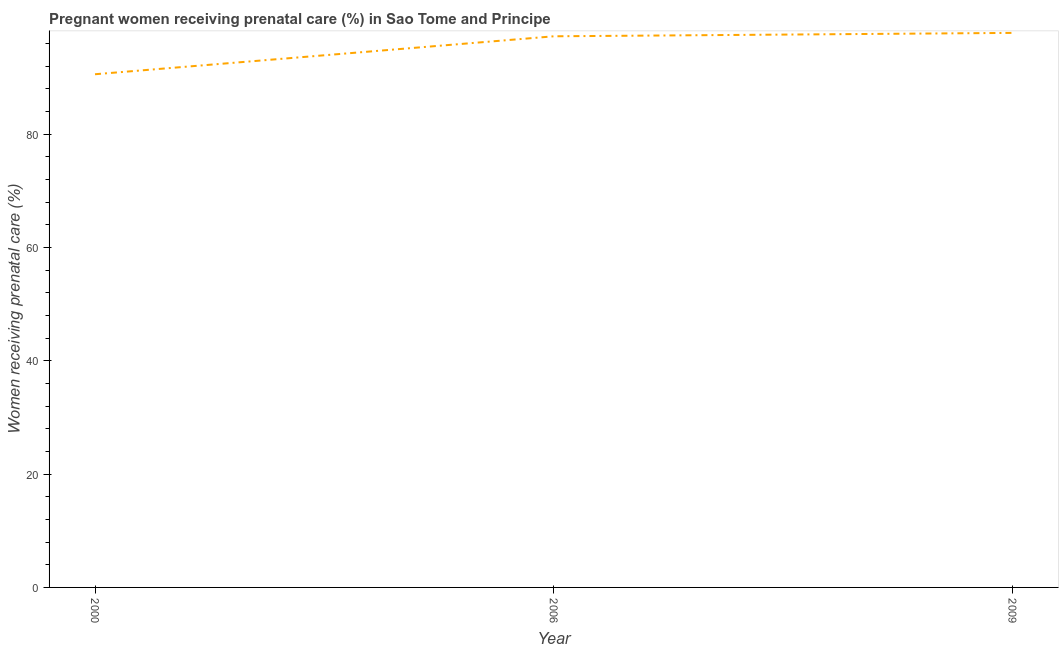What is the percentage of pregnant women receiving prenatal care in 2006?
Your answer should be very brief. 97.3. Across all years, what is the maximum percentage of pregnant women receiving prenatal care?
Keep it short and to the point. 97.9. Across all years, what is the minimum percentage of pregnant women receiving prenatal care?
Your response must be concise. 90.6. In which year was the percentage of pregnant women receiving prenatal care minimum?
Offer a terse response. 2000. What is the sum of the percentage of pregnant women receiving prenatal care?
Your answer should be very brief. 285.8. What is the difference between the percentage of pregnant women receiving prenatal care in 2000 and 2009?
Offer a very short reply. -7.3. What is the average percentage of pregnant women receiving prenatal care per year?
Your answer should be compact. 95.27. What is the median percentage of pregnant women receiving prenatal care?
Your answer should be very brief. 97.3. What is the ratio of the percentage of pregnant women receiving prenatal care in 2000 to that in 2009?
Offer a very short reply. 0.93. Is the percentage of pregnant women receiving prenatal care in 2000 less than that in 2006?
Provide a succinct answer. Yes. What is the difference between the highest and the second highest percentage of pregnant women receiving prenatal care?
Make the answer very short. 0.6. What is the difference between the highest and the lowest percentage of pregnant women receiving prenatal care?
Your answer should be compact. 7.3. In how many years, is the percentage of pregnant women receiving prenatal care greater than the average percentage of pregnant women receiving prenatal care taken over all years?
Your answer should be compact. 2. Are the values on the major ticks of Y-axis written in scientific E-notation?
Your answer should be compact. No. What is the title of the graph?
Provide a short and direct response. Pregnant women receiving prenatal care (%) in Sao Tome and Principe. What is the label or title of the X-axis?
Your answer should be very brief. Year. What is the label or title of the Y-axis?
Give a very brief answer. Women receiving prenatal care (%). What is the Women receiving prenatal care (%) of 2000?
Your answer should be compact. 90.6. What is the Women receiving prenatal care (%) in 2006?
Give a very brief answer. 97.3. What is the Women receiving prenatal care (%) of 2009?
Provide a succinct answer. 97.9. What is the difference between the Women receiving prenatal care (%) in 2006 and 2009?
Ensure brevity in your answer.  -0.6. What is the ratio of the Women receiving prenatal care (%) in 2000 to that in 2006?
Offer a very short reply. 0.93. What is the ratio of the Women receiving prenatal care (%) in 2000 to that in 2009?
Offer a terse response. 0.93. What is the ratio of the Women receiving prenatal care (%) in 2006 to that in 2009?
Make the answer very short. 0.99. 